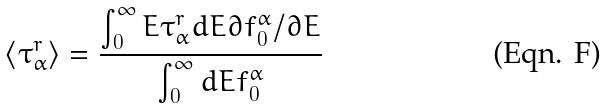<formula> <loc_0><loc_0><loc_500><loc_500>\langle \tau _ { \alpha } ^ { r } \rangle = \frac { \int _ { 0 } ^ { \infty } E \tau _ { \alpha } ^ { r } d E \partial f _ { 0 } ^ { \alpha } / \partial E } { \int _ { 0 } ^ { \infty } d E f _ { 0 } ^ { \alpha } }</formula> 